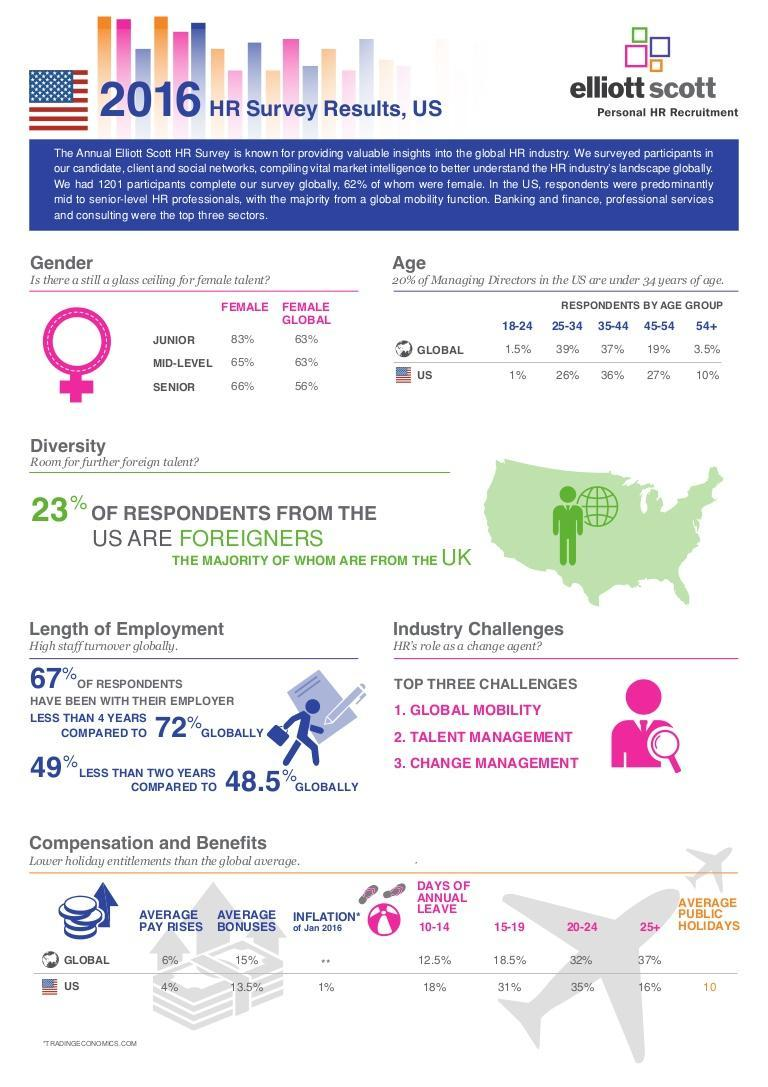According to the survey, what percentage of female employees globally believed that there is still a glass ceiling for female talents in senior level?
Answer the question with a short phrase. 56% What percentage is the average bonuses in the U.S. as per the 2016 HR survey? 13.5% What percentage is the average pay rises in the gobal level as per the 2016 HR survey? 6% What percentage of respondents in U.S. have been with their employer for more than 4 years? 33% What is the average public holidays offered for U.S. employees as per the 2016 HR survey? 10 What percentage of employees were working for less than two years with their employer globally? 48.5% According to the survey, what percentage of  female employees in U.S. believed that there is still a glass ceiling for female talents in junior level? 83% 